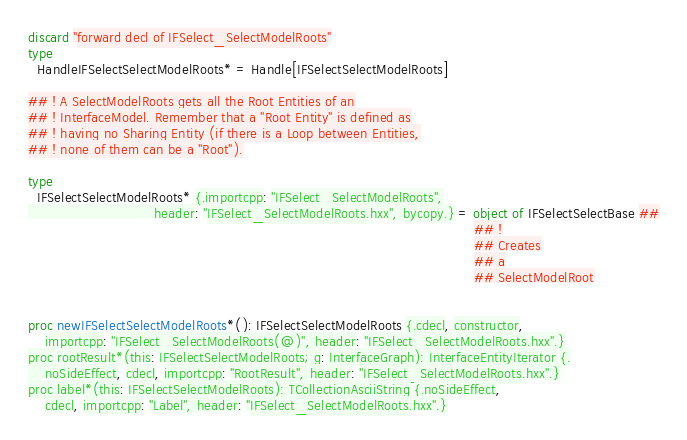<code> <loc_0><loc_0><loc_500><loc_500><_Nim_>discard "forward decl of IFSelect_SelectModelRoots"
type
  HandleIFSelectSelectModelRoots* = Handle[IFSelectSelectModelRoots]

## ! A SelectModelRoots gets all the Root Entities of an
## ! InterfaceModel. Remember that a "Root Entity" is defined as
## ! having no Sharing Entity (if there is a Loop between Entities,
## ! none of them can be a "Root").

type
  IFSelectSelectModelRoots* {.importcpp: "IFSelect_SelectModelRoots",
                             header: "IFSelect_SelectModelRoots.hxx", bycopy.} = object of IFSelectSelectBase ##
                                                                                                       ## !
                                                                                                       ## Creates
                                                                                                       ## a
                                                                                                       ## SelectModelRoot


proc newIFSelectSelectModelRoots*(): IFSelectSelectModelRoots {.cdecl, constructor,
    importcpp: "IFSelect_SelectModelRoots(@)", header: "IFSelect_SelectModelRoots.hxx".}
proc rootResult*(this: IFSelectSelectModelRoots; g: InterfaceGraph): InterfaceEntityIterator {.
    noSideEffect, cdecl, importcpp: "RootResult", header: "IFSelect_SelectModelRoots.hxx".}
proc label*(this: IFSelectSelectModelRoots): TCollectionAsciiString {.noSideEffect,
    cdecl, importcpp: "Label", header: "IFSelect_SelectModelRoots.hxx".}</code> 